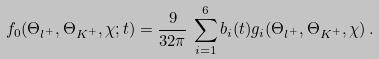<formula> <loc_0><loc_0><loc_500><loc_500>f _ { 0 } ( \Theta _ { l ^ { + } } , \Theta _ { K ^ { + } } , \chi ; t ) = \frac { 9 } { 3 2 \pi } \, \sum ^ { 6 } _ { i = 1 } b _ { i } ( t ) g _ { i } ( \Theta _ { l ^ { + } } , \Theta _ { K ^ { + } } , \chi ) \, .</formula> 